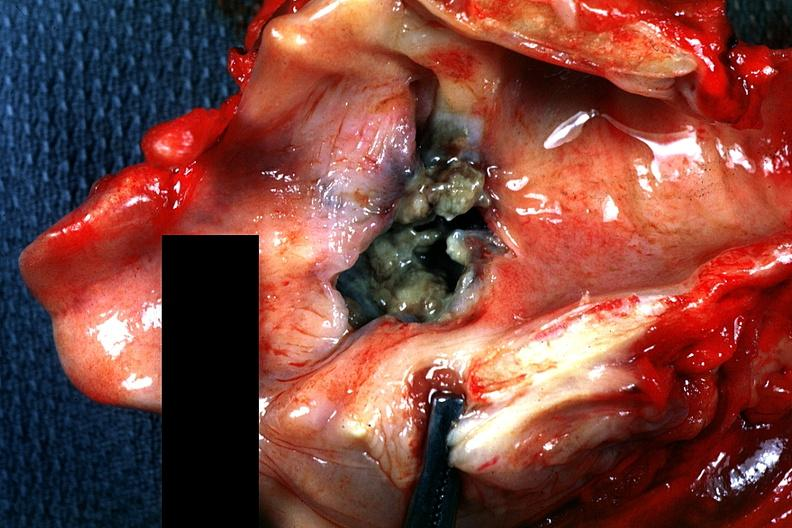s larynx present?
Answer the question using a single word or phrase. Yes 